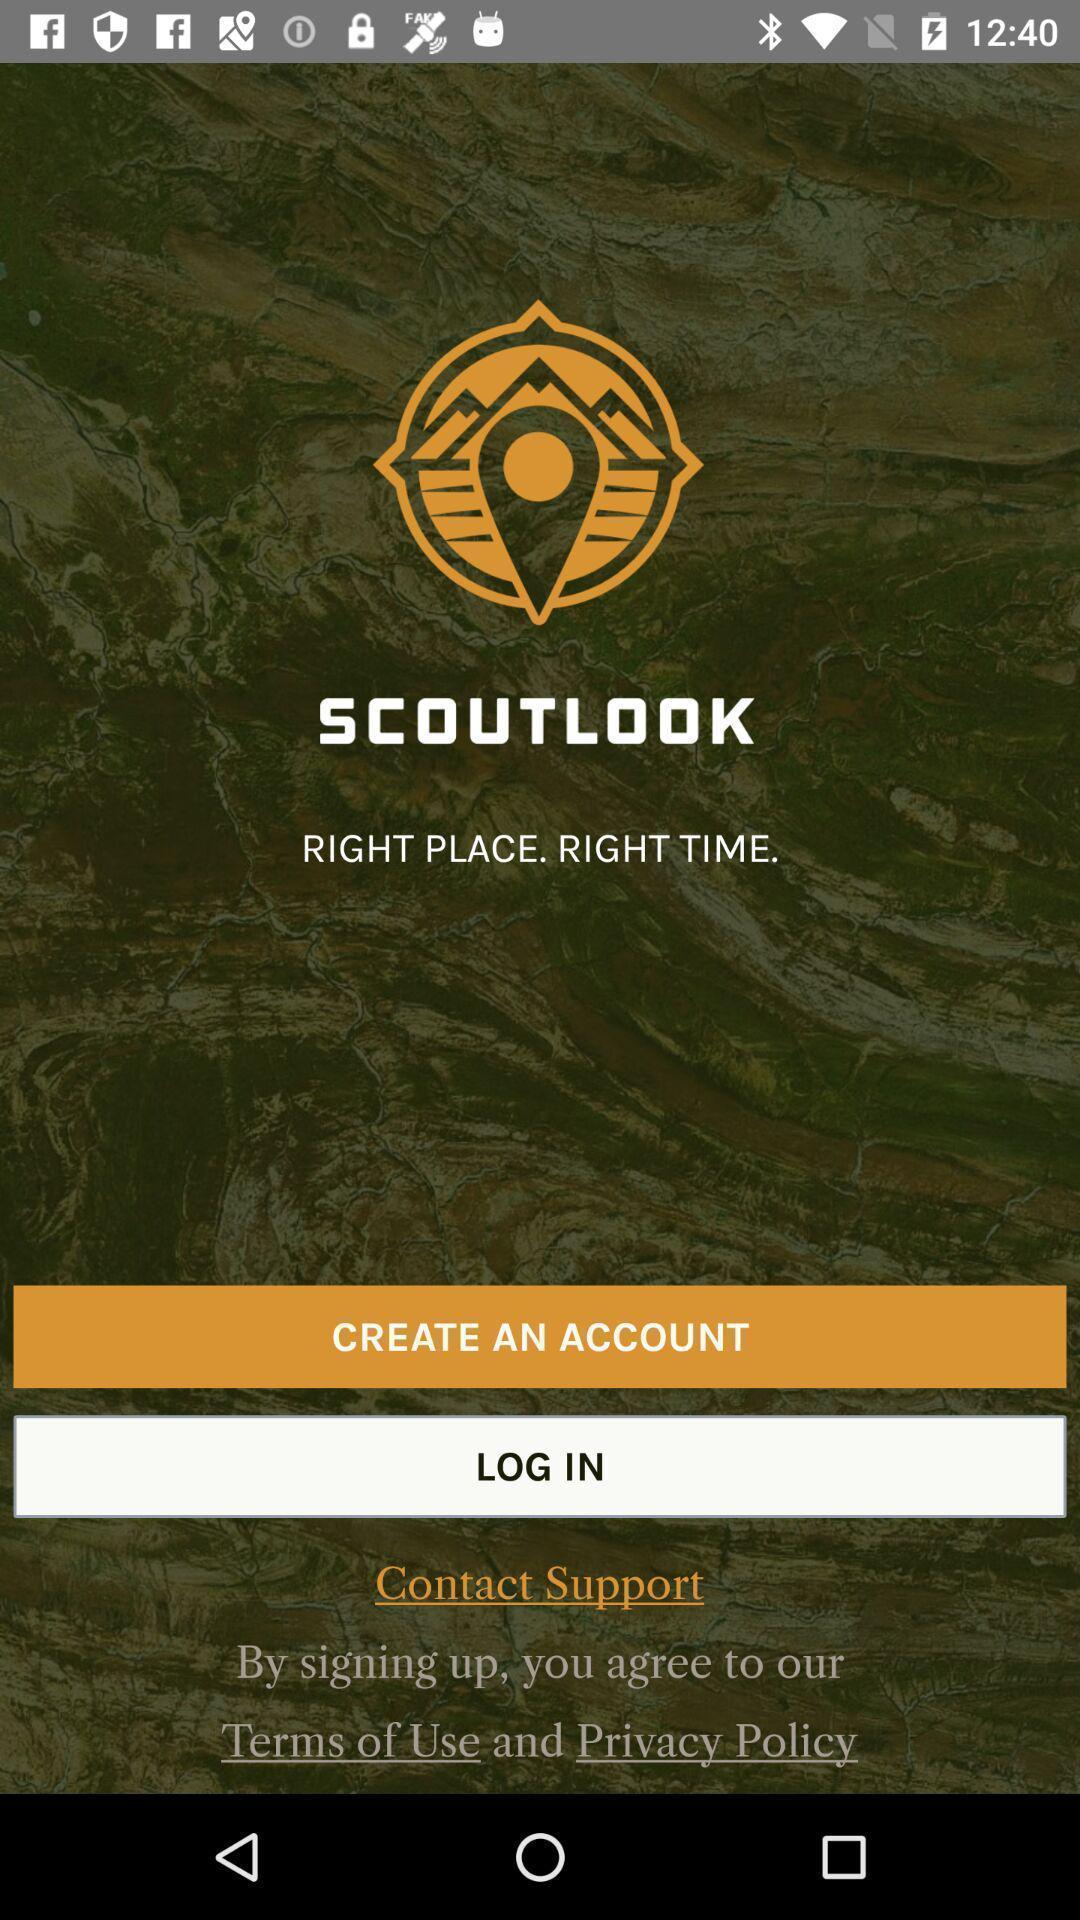What is the overall content of this screenshot? Welcome page of scout look. 